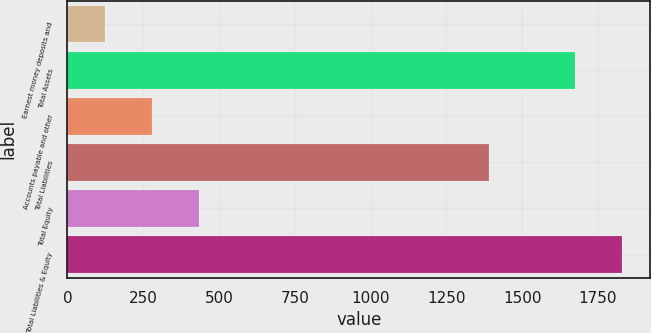Convert chart to OTSL. <chart><loc_0><loc_0><loc_500><loc_500><bar_chart><fcel>Earnest money deposits and<fcel>Total Assets<fcel>Accounts payable and other<fcel>Total Liabilities<fcel>Total Equity<fcel>Total Liabilities & Equity<nl><fcel>122.9<fcel>1675.3<fcel>278.14<fcel>1390.6<fcel>433.38<fcel>1830.54<nl></chart> 